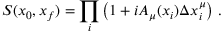Convert formula to latex. <formula><loc_0><loc_0><loc_500><loc_500>S ( x _ { 0 } , x _ { f } ) = \prod _ { i } \left ( 1 + i A _ { \mu } ( x _ { i } ) \Delta x _ { i } ^ { \mu } \right ) \, .</formula> 